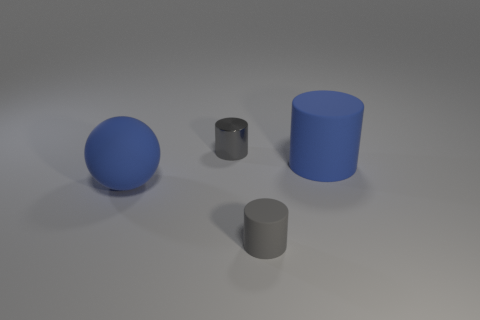Add 4 big rubber objects. How many objects exist? 8 Subtract all balls. How many objects are left? 3 Subtract 0 purple spheres. How many objects are left? 4 Subtract all large purple shiny objects. Subtract all small gray rubber things. How many objects are left? 3 Add 1 shiny objects. How many shiny objects are left? 2 Add 4 blue spheres. How many blue spheres exist? 5 